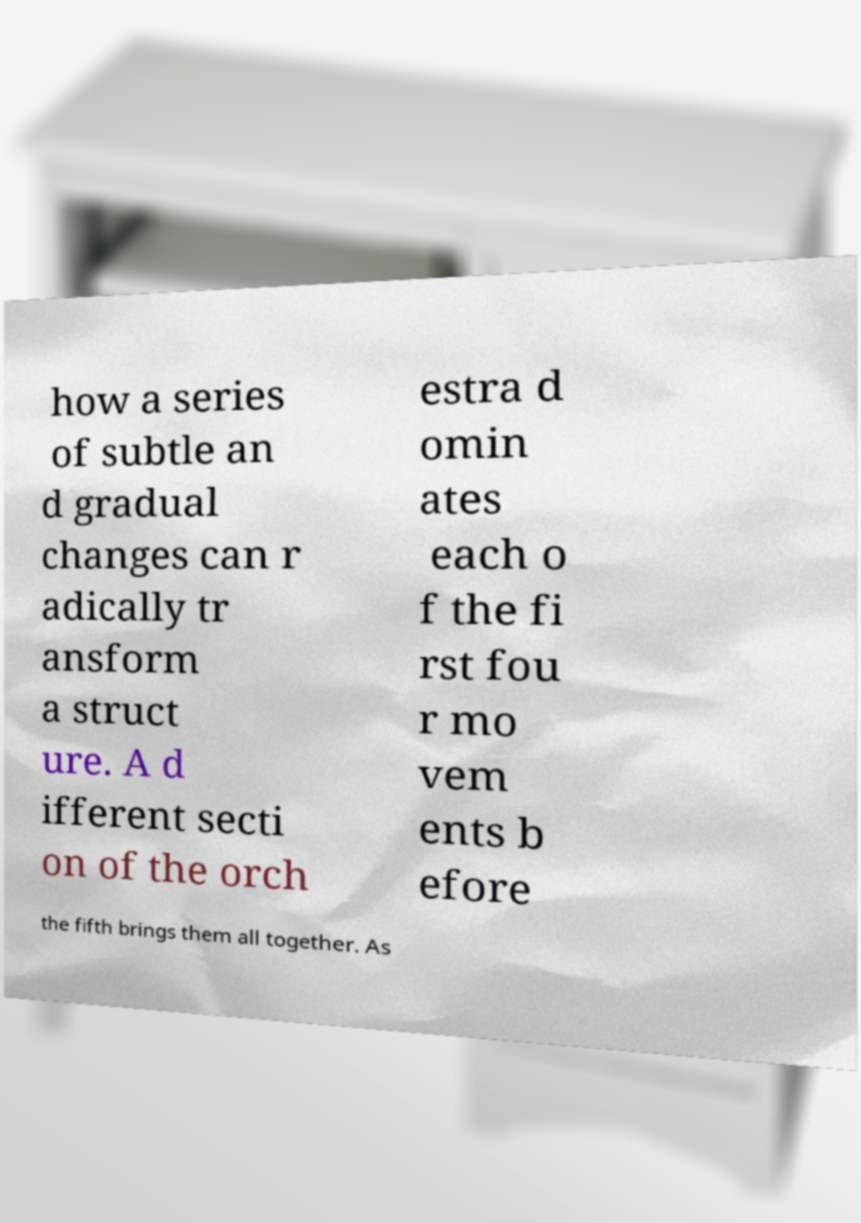Could you assist in decoding the text presented in this image and type it out clearly? how a series of subtle an d gradual changes can r adically tr ansform a struct ure. A d ifferent secti on of the orch estra d omin ates each o f the fi rst fou r mo vem ents b efore the fifth brings them all together. As 